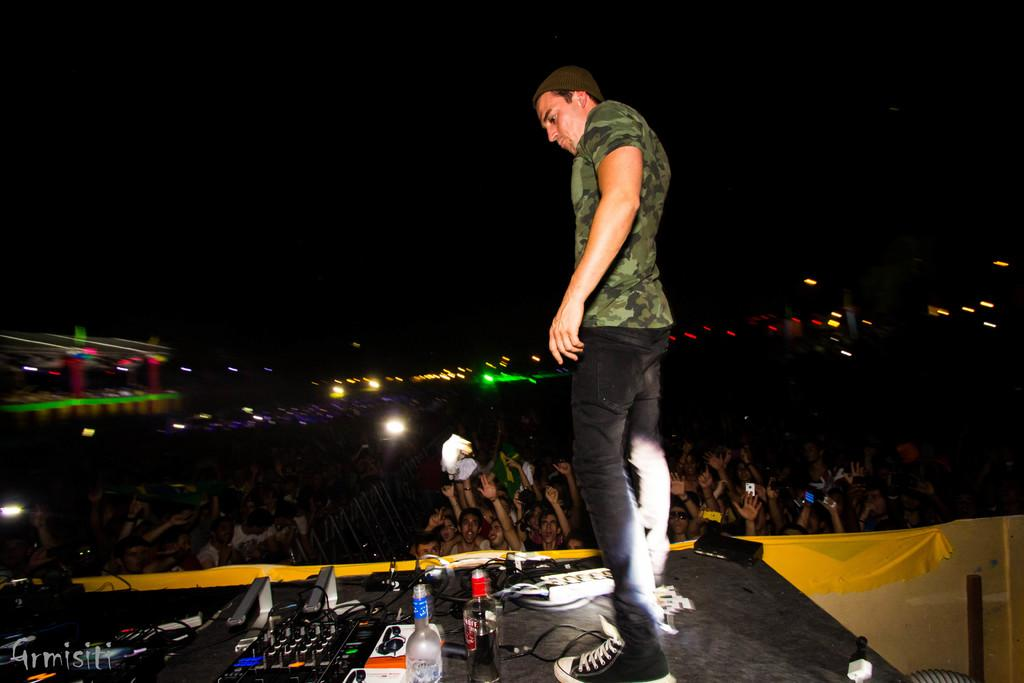What is the person doing in the image? The person is standing on a stage. What objects are on the stage with the person? There are bottles and devices on the stage. Who can be seen in the background of the image? There is an audience in the background. What can be seen in the background besides the audience? There are lights in the background. What type of print can be seen on the person's shirt in the image? There is no print visible on the person's shirt in the image. What kind of beast is present on the stage with the person? There are no animals or beasts present on the stage with the person; only bottles and devices are visible. 